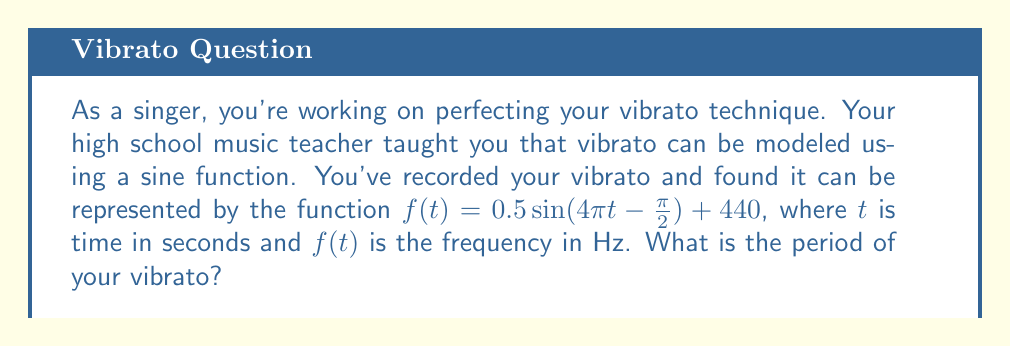Can you answer this question? Let's approach this step-by-step:

1) The general form of a sine function is:
   $$ a\sin(b(t-c)) + d $$
   where $b$ affects the period of the function.

2) In our case, we have:
   $$ 0.5\sin(4\pi t - \frac{\pi}{2}) + 440 $$

3) Comparing this to the general form, we can see that $b = 4\pi$.

4) The period of a sine function is given by the formula:
   $$ \text{Period} = \frac{2\pi}{|b|} $$

5) Substituting our value of $b$:
   $$ \text{Period} = \frac{2\pi}{|4\pi|} = \frac{2\pi}{4\pi} = \frac{1}{2} $$

6) Therefore, the period of the vibrato is 0.5 seconds.
Answer: $0.5$ seconds 